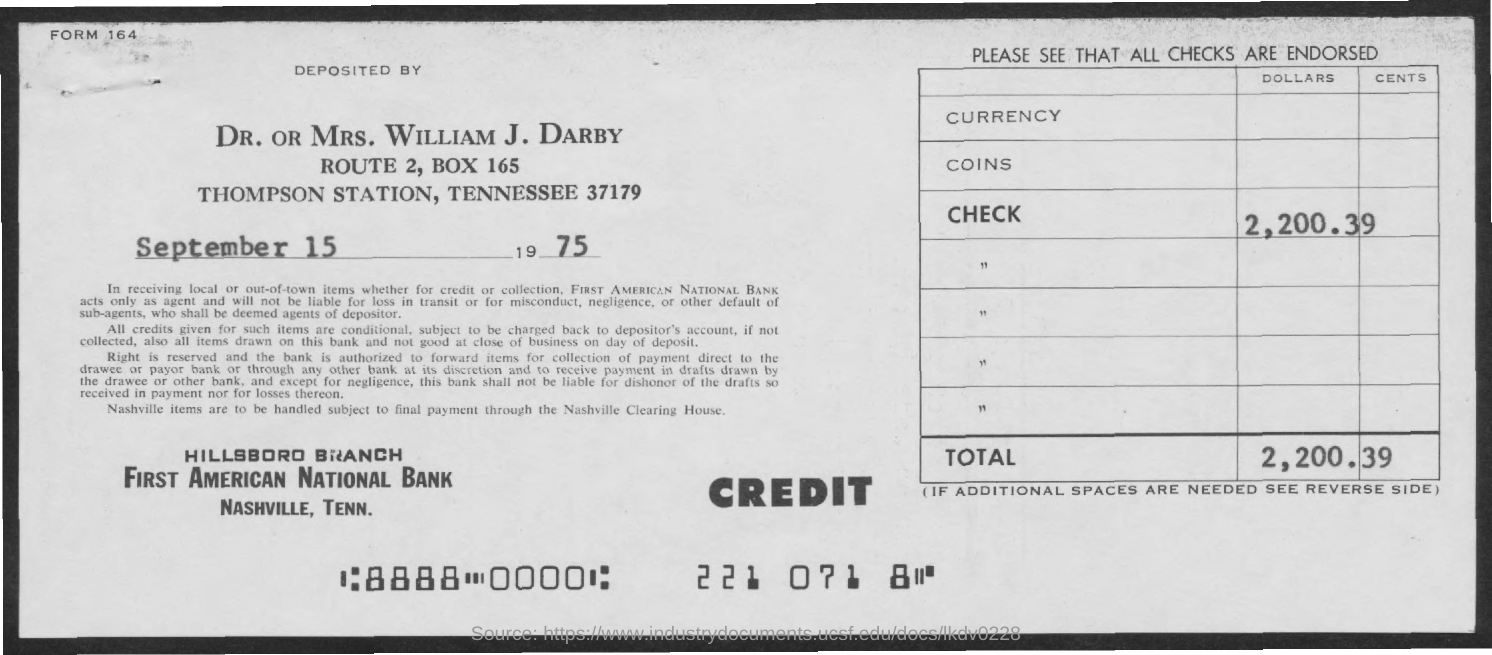What is the amount of check in dollars?
Your answer should be very brief. 2,200.39. What is the Form No mentioned in the document?
Make the answer very short. 164. Who has deposited the check amount as per the document?
Make the answer very short. WILLIAM J. DARBY. What is the deposit date as per the document?
Make the answer very short. September 15, 1975. 